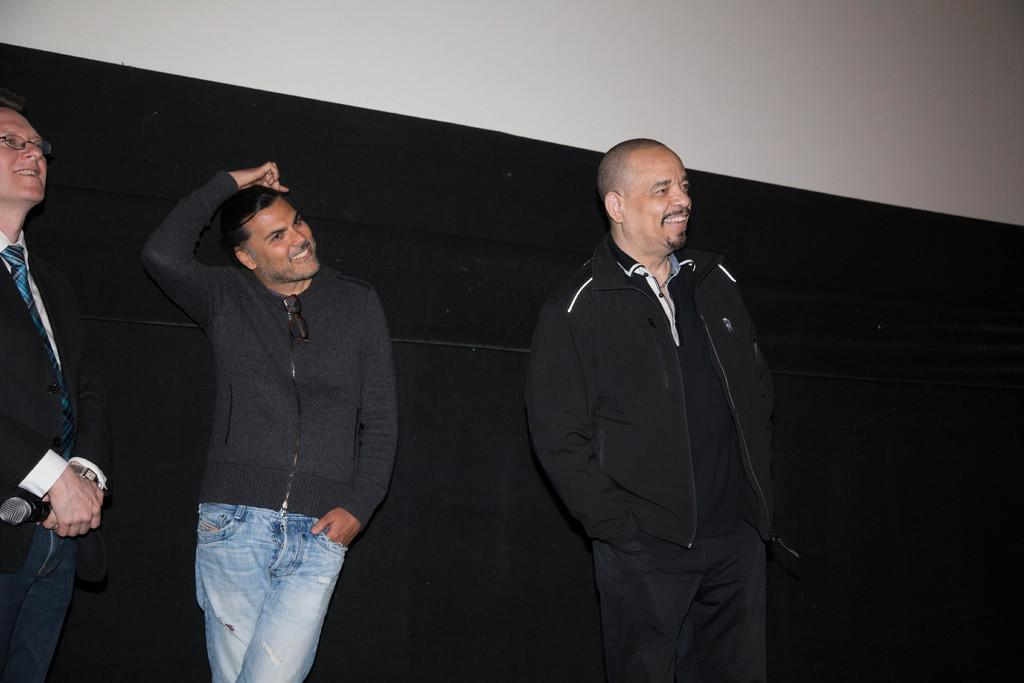How many men are in the image? There are three men in the image. What is the facial expression of the men in the image? The men are smiling. Can you describe the position of the man on the right side of the image? The man on the right side is holding a microphone. What type of apple is being offered to the beggar in the image? There is no apple or beggar present in the image; it features three men, all of whom are smiling. 